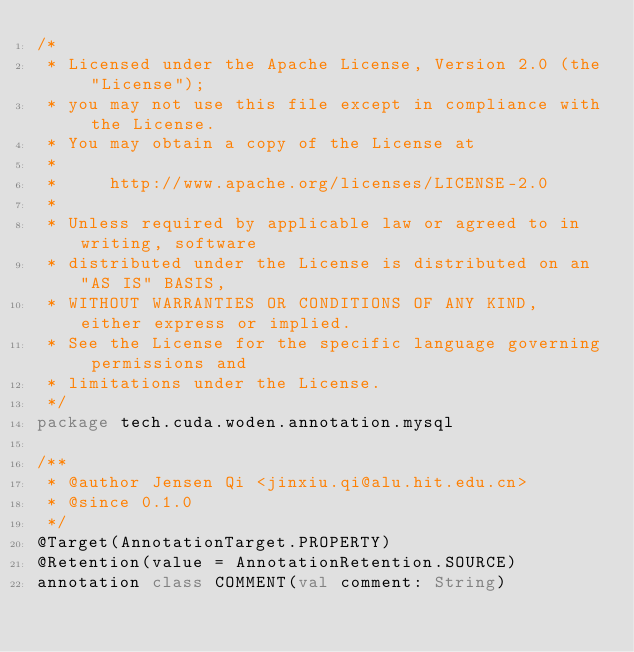Convert code to text. <code><loc_0><loc_0><loc_500><loc_500><_Kotlin_>/*
 * Licensed under the Apache License, Version 2.0 (the "License");
 * you may not use this file except in compliance with the License.
 * You may obtain a copy of the License at
 *
 *     http://www.apache.org/licenses/LICENSE-2.0
 *
 * Unless required by applicable law or agreed to in writing, software
 * distributed under the License is distributed on an "AS IS" BASIS,
 * WITHOUT WARRANTIES OR CONDITIONS OF ANY KIND, either express or implied.
 * See the License for the specific language governing permissions and
 * limitations under the License.
 */
package tech.cuda.woden.annotation.mysql

/**
 * @author Jensen Qi <jinxiu.qi@alu.hit.edu.cn>
 * @since 0.1.0
 */
@Target(AnnotationTarget.PROPERTY)
@Retention(value = AnnotationRetention.SOURCE)
annotation class COMMENT(val comment: String)</code> 